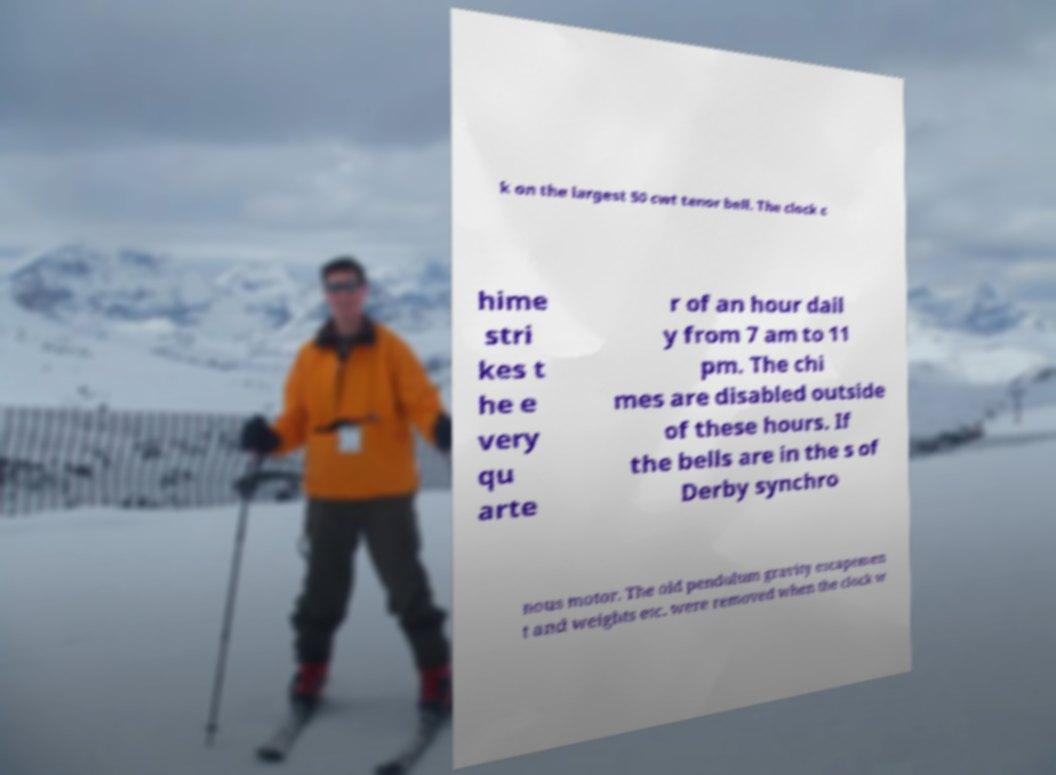There's text embedded in this image that I need extracted. Can you transcribe it verbatim? k on the largest 50 cwt tenor bell. The clock c hime stri kes t he e very qu arte r of an hour dail y from 7 am to 11 pm. The chi mes are disabled outside of these hours. If the bells are in the s of Derby synchro nous motor. The old pendulum gravity escapemen t and weights etc. were removed when the clock w 